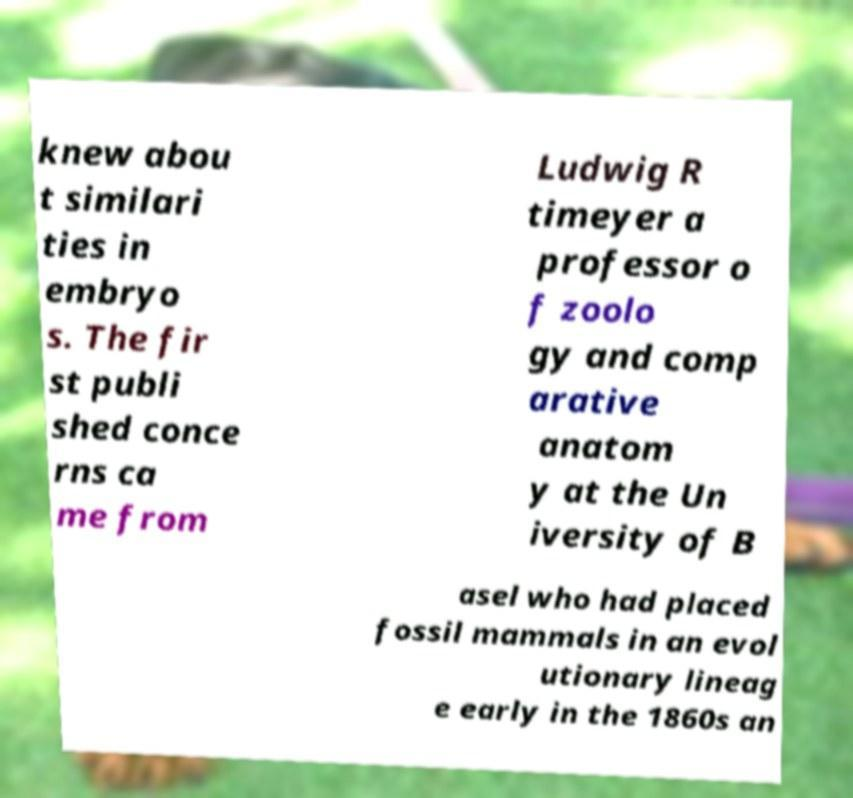For documentation purposes, I need the text within this image transcribed. Could you provide that? knew abou t similari ties in embryo s. The fir st publi shed conce rns ca me from Ludwig R timeyer a professor o f zoolo gy and comp arative anatom y at the Un iversity of B asel who had placed fossil mammals in an evol utionary lineag e early in the 1860s an 